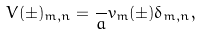Convert formula to latex. <formula><loc_0><loc_0><loc_500><loc_500>V ( \pm ) _ { m , n } = \frac { } { a } v _ { m } ( \pm ) \delta _ { m , n } ,</formula> 